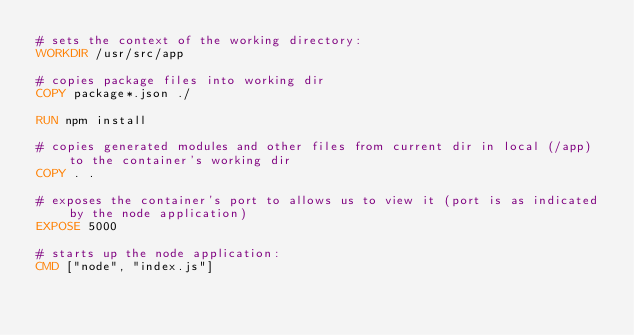Convert code to text. <code><loc_0><loc_0><loc_500><loc_500><_Dockerfile_># sets the context of the working directory:
WORKDIR /usr/src/app

# copies package files into working dir
COPY package*.json ./

RUN npm install 

# copies generated modules and other files from current dir in local (/app) to the container's working dir
COPY . .

# exposes the container's port to allows us to view it (port is as indicated by the node application)
EXPOSE 5000

# starts up the node application:
CMD ["node", "index.js"]
</code> 